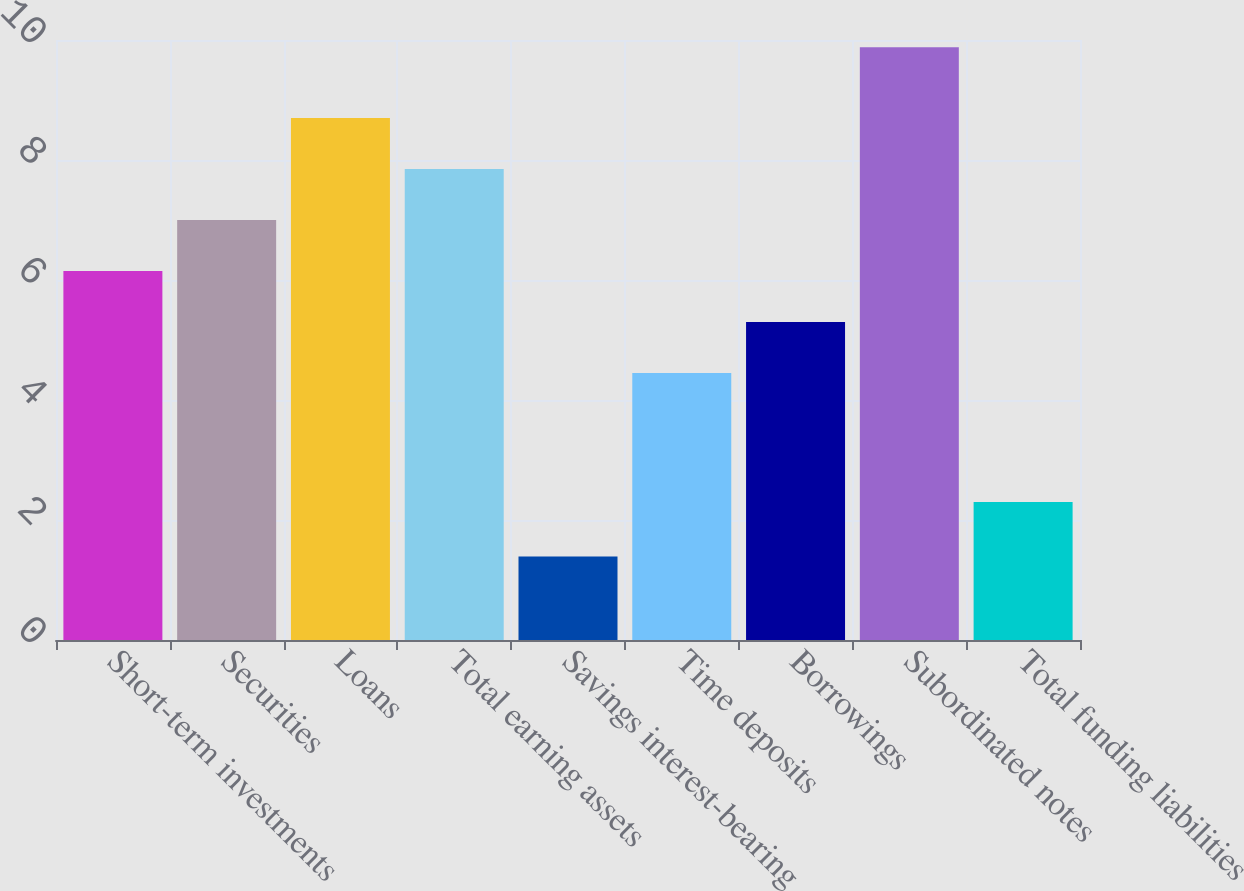Convert chart to OTSL. <chart><loc_0><loc_0><loc_500><loc_500><bar_chart><fcel>Short-term investments<fcel>Securities<fcel>Loans<fcel>Total earning assets<fcel>Savings interest-bearing<fcel>Time deposits<fcel>Borrowings<fcel>Subordinated notes<fcel>Total funding liabilities<nl><fcel>6.15<fcel>7<fcel>8.7<fcel>7.85<fcel>1.39<fcel>4.45<fcel>5.3<fcel>9.88<fcel>2.3<nl></chart> 